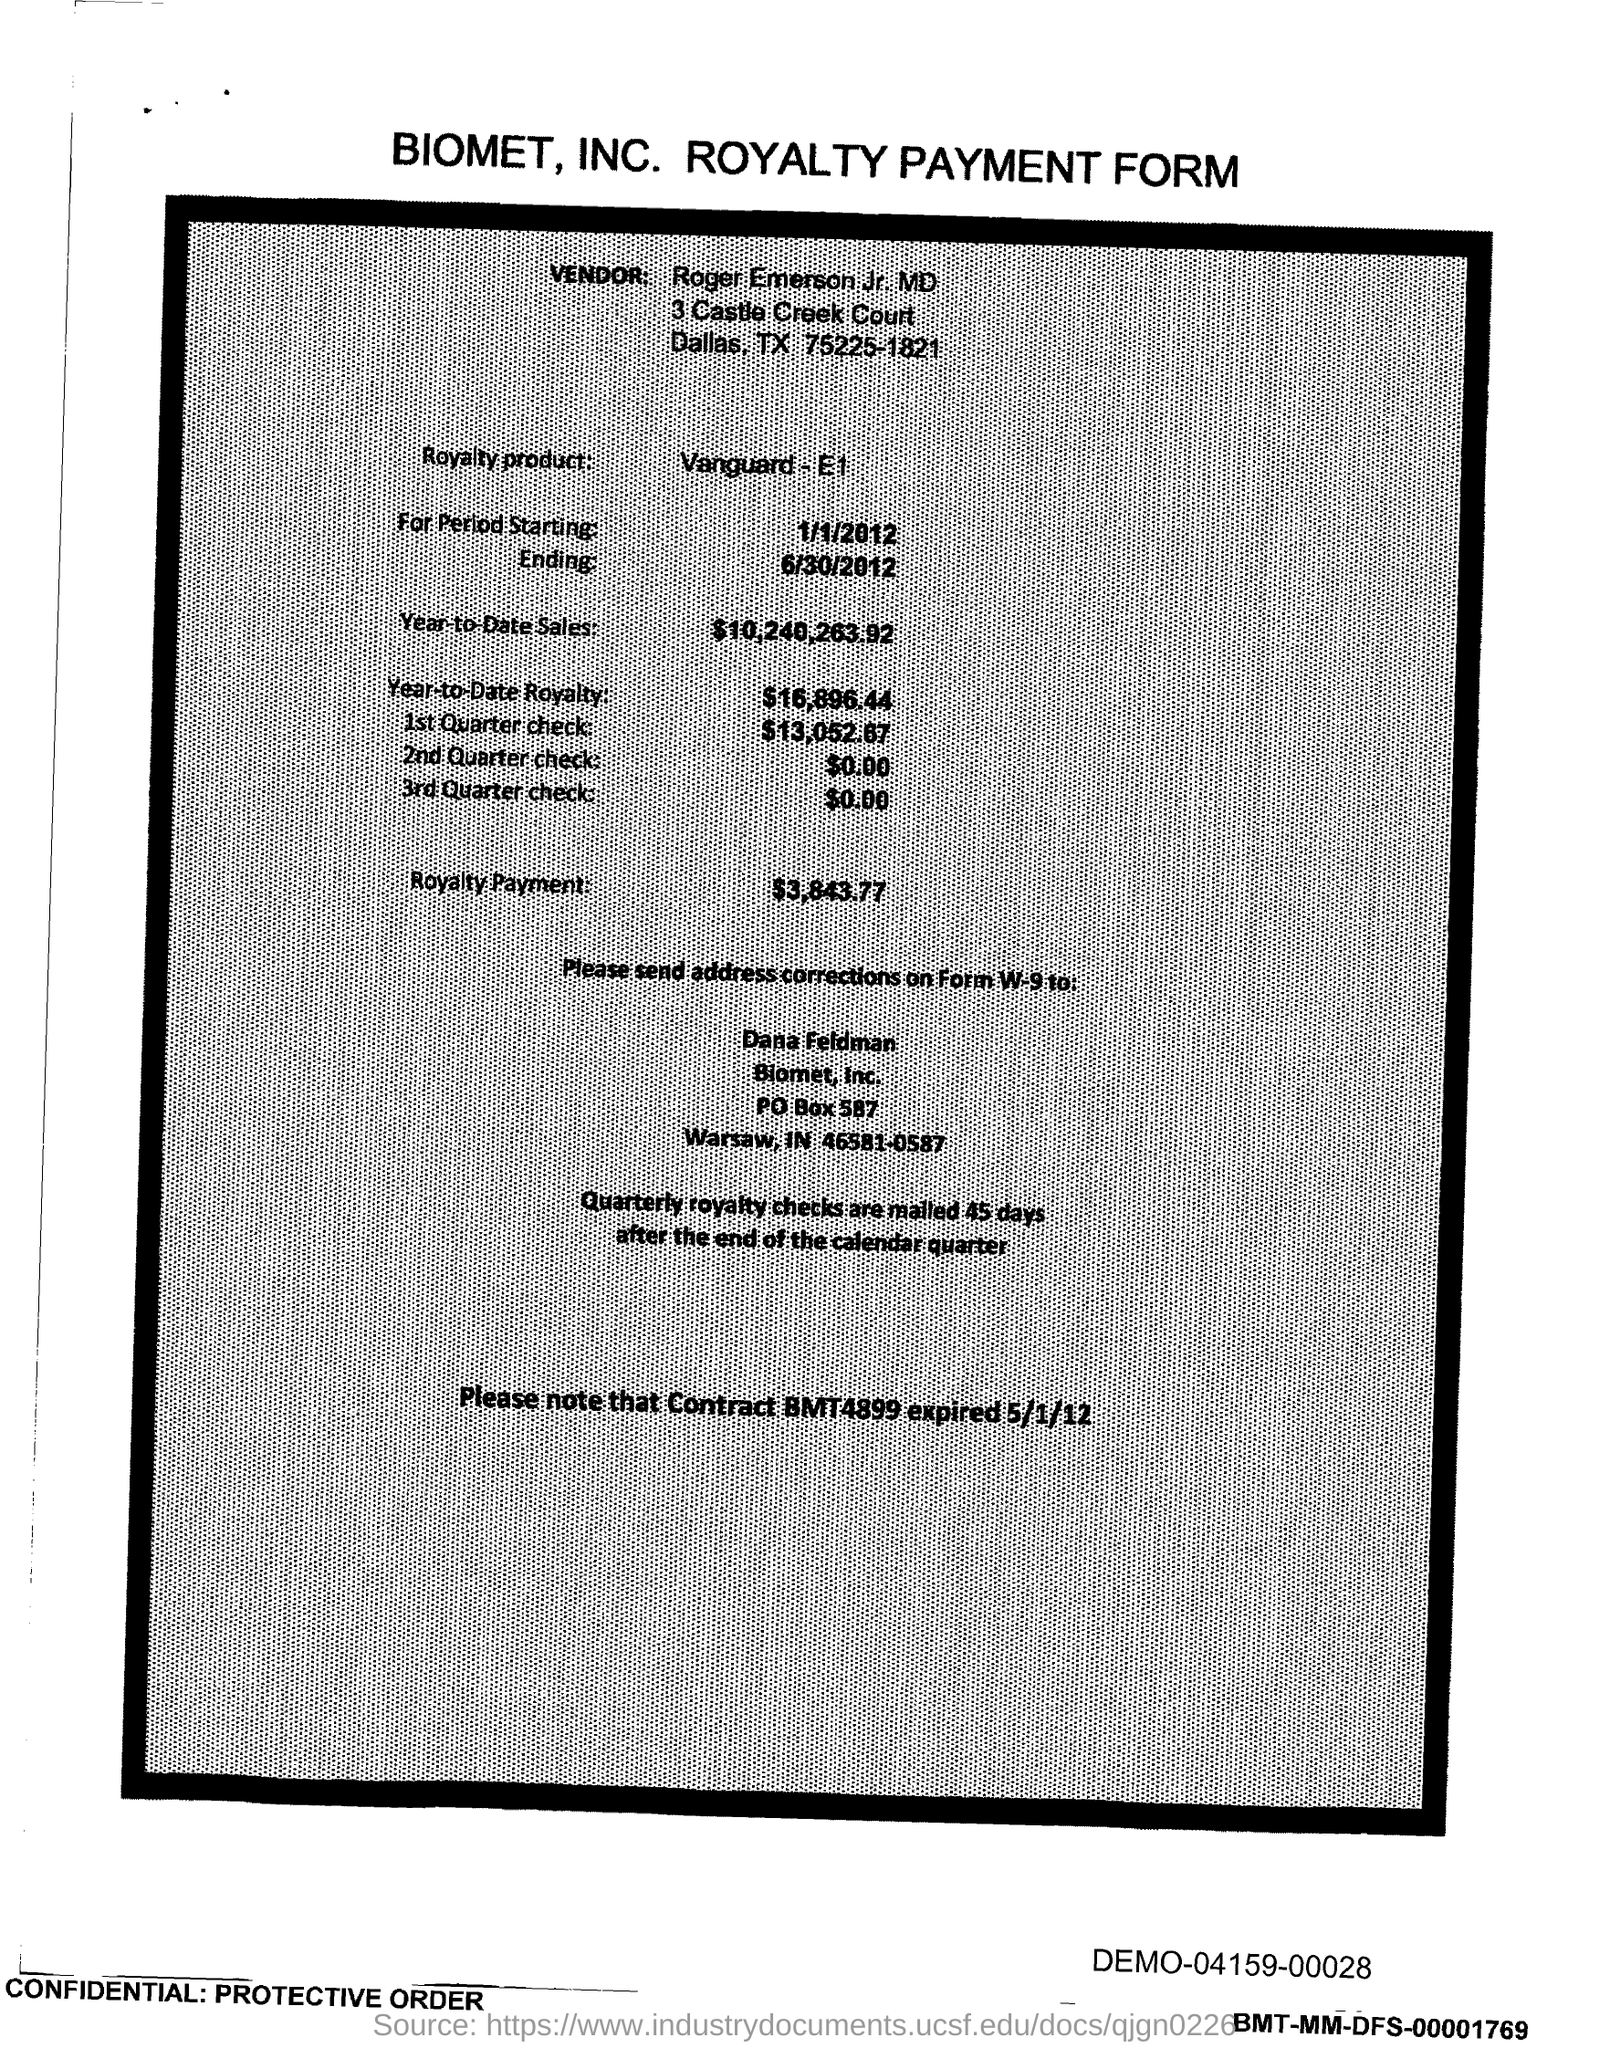Highlight a few significant elements in this photo. The amount mentioned in the form for the 2nd Quarter check is $0.00. The amount of the 1st quarter check mentioned in the form is $13,052.67. The royalty period ended on June 30, 2012. The vendor name mentioned in the form is Roger Emerson Jr., MD. The start date of the royalty period is January 1, 2012. 